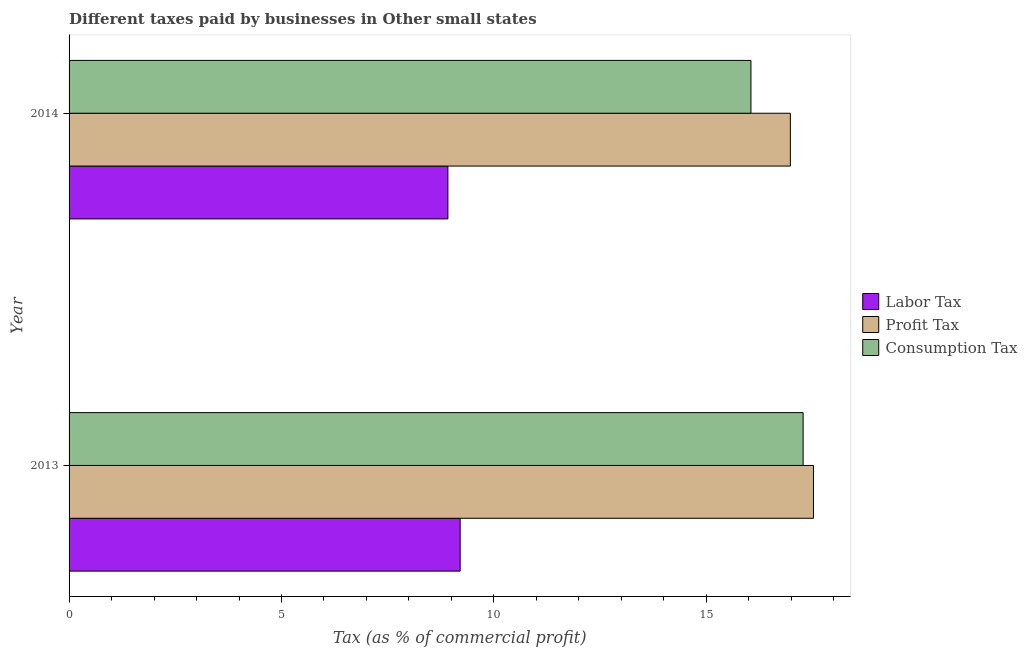Are the number of bars per tick equal to the number of legend labels?
Your response must be concise. Yes. How many bars are there on the 1st tick from the top?
Offer a very short reply. 3. How many bars are there on the 1st tick from the bottom?
Offer a terse response. 3. What is the label of the 1st group of bars from the top?
Your answer should be very brief. 2014. What is the percentage of profit tax in 2014?
Offer a terse response. 16.98. Across all years, what is the maximum percentage of consumption tax?
Your answer should be compact. 17.28. Across all years, what is the minimum percentage of profit tax?
Ensure brevity in your answer.  16.98. In which year was the percentage of consumption tax minimum?
Provide a succinct answer. 2014. What is the total percentage of consumption tax in the graph?
Your answer should be compact. 33.33. What is the difference between the percentage of profit tax in 2013 and that in 2014?
Offer a very short reply. 0.54. What is the difference between the percentage of labor tax in 2013 and the percentage of profit tax in 2014?
Offer a terse response. -7.77. What is the average percentage of profit tax per year?
Offer a very short reply. 17.25. In the year 2014, what is the difference between the percentage of profit tax and percentage of consumption tax?
Offer a terse response. 0.93. What is the ratio of the percentage of labor tax in 2013 to that in 2014?
Provide a succinct answer. 1.03. Is the difference between the percentage of labor tax in 2013 and 2014 greater than the difference between the percentage of consumption tax in 2013 and 2014?
Your response must be concise. No. What does the 3rd bar from the top in 2013 represents?
Your response must be concise. Labor Tax. What does the 2nd bar from the bottom in 2014 represents?
Make the answer very short. Profit Tax. How many bars are there?
Keep it short and to the point. 6. Are all the bars in the graph horizontal?
Provide a succinct answer. Yes. How many years are there in the graph?
Provide a short and direct response. 2. Are the values on the major ticks of X-axis written in scientific E-notation?
Make the answer very short. No. How many legend labels are there?
Provide a short and direct response. 3. How are the legend labels stacked?
Make the answer very short. Vertical. What is the title of the graph?
Offer a very short reply. Different taxes paid by businesses in Other small states. Does "Ages 65 and above" appear as one of the legend labels in the graph?
Keep it short and to the point. No. What is the label or title of the X-axis?
Your answer should be compact. Tax (as % of commercial profit). What is the Tax (as % of commercial profit) in Labor Tax in 2013?
Your answer should be very brief. 9.21. What is the Tax (as % of commercial profit) of Profit Tax in 2013?
Keep it short and to the point. 17.52. What is the Tax (as % of commercial profit) of Consumption Tax in 2013?
Offer a very short reply. 17.28. What is the Tax (as % of commercial profit) of Labor Tax in 2014?
Your answer should be very brief. 8.92. What is the Tax (as % of commercial profit) of Profit Tax in 2014?
Provide a short and direct response. 16.98. What is the Tax (as % of commercial profit) in Consumption Tax in 2014?
Offer a terse response. 16.05. Across all years, what is the maximum Tax (as % of commercial profit) in Labor Tax?
Provide a short and direct response. 9.21. Across all years, what is the maximum Tax (as % of commercial profit) of Profit Tax?
Give a very brief answer. 17.52. Across all years, what is the maximum Tax (as % of commercial profit) in Consumption Tax?
Ensure brevity in your answer.  17.28. Across all years, what is the minimum Tax (as % of commercial profit) of Labor Tax?
Your answer should be compact. 8.92. Across all years, what is the minimum Tax (as % of commercial profit) in Profit Tax?
Keep it short and to the point. 16.98. Across all years, what is the minimum Tax (as % of commercial profit) of Consumption Tax?
Ensure brevity in your answer.  16.05. What is the total Tax (as % of commercial profit) of Labor Tax in the graph?
Ensure brevity in your answer.  18.12. What is the total Tax (as % of commercial profit) in Profit Tax in the graph?
Your answer should be very brief. 34.5. What is the total Tax (as % of commercial profit) in Consumption Tax in the graph?
Give a very brief answer. 33.33. What is the difference between the Tax (as % of commercial profit) in Labor Tax in 2013 and that in 2014?
Make the answer very short. 0.29. What is the difference between the Tax (as % of commercial profit) in Profit Tax in 2013 and that in 2014?
Provide a succinct answer. 0.54. What is the difference between the Tax (as % of commercial profit) of Consumption Tax in 2013 and that in 2014?
Provide a succinct answer. 1.23. What is the difference between the Tax (as % of commercial profit) in Labor Tax in 2013 and the Tax (as % of commercial profit) in Profit Tax in 2014?
Give a very brief answer. -7.77. What is the difference between the Tax (as % of commercial profit) of Labor Tax in 2013 and the Tax (as % of commercial profit) of Consumption Tax in 2014?
Your answer should be very brief. -6.84. What is the difference between the Tax (as % of commercial profit) in Profit Tax in 2013 and the Tax (as % of commercial profit) in Consumption Tax in 2014?
Provide a succinct answer. 1.47. What is the average Tax (as % of commercial profit) in Labor Tax per year?
Provide a succinct answer. 9.06. What is the average Tax (as % of commercial profit) in Profit Tax per year?
Provide a short and direct response. 17.25. What is the average Tax (as % of commercial profit) of Consumption Tax per year?
Offer a terse response. 16.66. In the year 2013, what is the difference between the Tax (as % of commercial profit) in Labor Tax and Tax (as % of commercial profit) in Profit Tax?
Your response must be concise. -8.32. In the year 2013, what is the difference between the Tax (as % of commercial profit) of Labor Tax and Tax (as % of commercial profit) of Consumption Tax?
Your answer should be very brief. -8.07. In the year 2013, what is the difference between the Tax (as % of commercial profit) in Profit Tax and Tax (as % of commercial profit) in Consumption Tax?
Offer a very short reply. 0.24. In the year 2014, what is the difference between the Tax (as % of commercial profit) of Labor Tax and Tax (as % of commercial profit) of Profit Tax?
Your response must be concise. -8.06. In the year 2014, what is the difference between the Tax (as % of commercial profit) in Labor Tax and Tax (as % of commercial profit) in Consumption Tax?
Provide a short and direct response. -7.13. In the year 2014, what is the difference between the Tax (as % of commercial profit) of Profit Tax and Tax (as % of commercial profit) of Consumption Tax?
Your answer should be very brief. 0.93. What is the ratio of the Tax (as % of commercial profit) in Labor Tax in 2013 to that in 2014?
Provide a short and direct response. 1.03. What is the ratio of the Tax (as % of commercial profit) of Profit Tax in 2013 to that in 2014?
Provide a succinct answer. 1.03. What is the ratio of the Tax (as % of commercial profit) of Consumption Tax in 2013 to that in 2014?
Your answer should be compact. 1.08. What is the difference between the highest and the second highest Tax (as % of commercial profit) in Labor Tax?
Your response must be concise. 0.29. What is the difference between the highest and the second highest Tax (as % of commercial profit) in Profit Tax?
Make the answer very short. 0.54. What is the difference between the highest and the second highest Tax (as % of commercial profit) of Consumption Tax?
Give a very brief answer. 1.23. What is the difference between the highest and the lowest Tax (as % of commercial profit) in Labor Tax?
Ensure brevity in your answer.  0.29. What is the difference between the highest and the lowest Tax (as % of commercial profit) of Profit Tax?
Give a very brief answer. 0.54. What is the difference between the highest and the lowest Tax (as % of commercial profit) of Consumption Tax?
Keep it short and to the point. 1.23. 